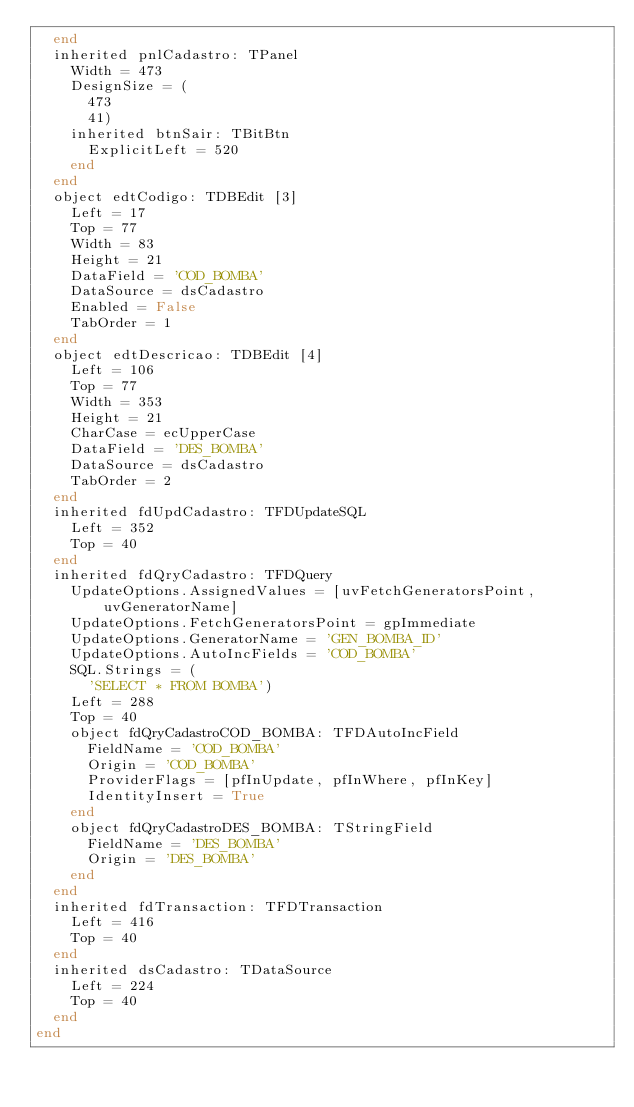Convert code to text. <code><loc_0><loc_0><loc_500><loc_500><_Pascal_>  end
  inherited pnlCadastro: TPanel
    Width = 473
    DesignSize = (
      473
      41)
    inherited btnSair: TBitBtn
      ExplicitLeft = 520
    end
  end
  object edtCodigo: TDBEdit [3]
    Left = 17
    Top = 77
    Width = 83
    Height = 21
    DataField = 'COD_BOMBA'
    DataSource = dsCadastro
    Enabled = False
    TabOrder = 1
  end
  object edtDescricao: TDBEdit [4]
    Left = 106
    Top = 77
    Width = 353
    Height = 21
    CharCase = ecUpperCase
    DataField = 'DES_BOMBA'
    DataSource = dsCadastro
    TabOrder = 2
  end
  inherited fdUpdCadastro: TFDUpdateSQL
    Left = 352
    Top = 40
  end
  inherited fdQryCadastro: TFDQuery
    UpdateOptions.AssignedValues = [uvFetchGeneratorsPoint, uvGeneratorName]
    UpdateOptions.FetchGeneratorsPoint = gpImmediate
    UpdateOptions.GeneratorName = 'GEN_BOMBA_ID'
    UpdateOptions.AutoIncFields = 'COD_BOMBA'
    SQL.Strings = (
      'SELECT * FROM BOMBA')
    Left = 288
    Top = 40
    object fdQryCadastroCOD_BOMBA: TFDAutoIncField
      FieldName = 'COD_BOMBA'
      Origin = 'COD_BOMBA'
      ProviderFlags = [pfInUpdate, pfInWhere, pfInKey]
      IdentityInsert = True
    end
    object fdQryCadastroDES_BOMBA: TStringField
      FieldName = 'DES_BOMBA'
      Origin = 'DES_BOMBA'
    end
  end
  inherited fdTransaction: TFDTransaction
    Left = 416
    Top = 40
  end
  inherited dsCadastro: TDataSource
    Left = 224
    Top = 40
  end
end
</code> 